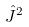Convert formula to latex. <formula><loc_0><loc_0><loc_500><loc_500>\hat { J } ^ { 2 }</formula> 